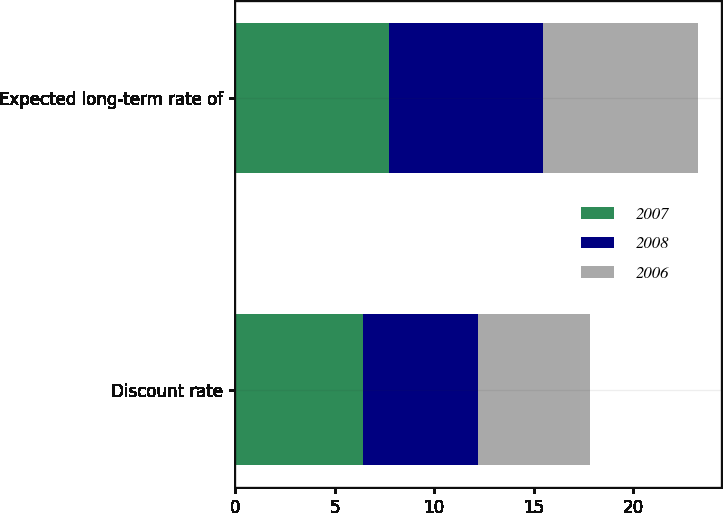<chart> <loc_0><loc_0><loc_500><loc_500><stacked_bar_chart><ecel><fcel>Discount rate<fcel>Expected long-term rate of<nl><fcel>2007<fcel>6.41<fcel>7.75<nl><fcel>2008<fcel>5.8<fcel>7.75<nl><fcel>2006<fcel>5.65<fcel>7.75<nl></chart> 